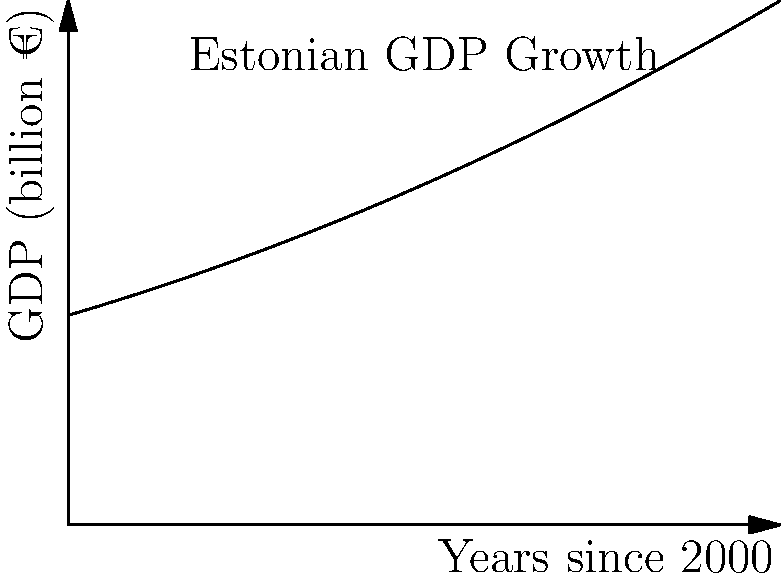The graph above represents Estonia's GDP growth (in billion euros) since the year 2000. The function modeling this growth is given by $f(x) = 20 + 2x + 0.1x^2$, where $x$ represents the number of years since 2000. Calculate the total increase in Estonia's GDP from 2000 to 2010 using integral calculus. To find the total increase in Estonia's GDP from 2000 to 2010, we need to calculate the area under the curve from $x=0$ to $x=10$. This can be done using a definite integral.

1. Set up the integral:
   $$\int_0^{10} (20 + 2x + 0.1x^2) dx$$

2. Integrate the function:
   $$\left[20x + x^2 + \frac{1}{3}x^3\right]_0^{10}$$

3. Evaluate the integral:
   $$(200 + 100 + \frac{1000}{3}) - (0 + 0 + 0)$$

4. Simplify:
   $$200 + 100 + \frac{1000}{3} = 300 + \frac{1000}{3} = \frac{900 + 1000}{3} = \frac{1900}{3}$$

5. Calculate the final result:
   $$\frac{1900}{3} \approx 633.33$$

The total increase in Estonia's GDP from 2000 to 2010 is approximately 633.33 billion euros.
Answer: 633.33 billion euros 